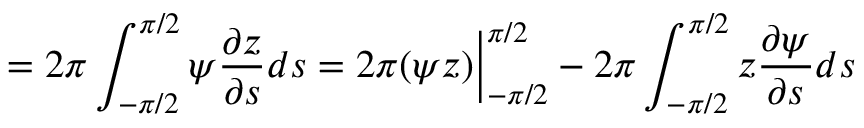<formula> <loc_0><loc_0><loc_500><loc_500>= 2 \pi \int _ { - \pi / 2 } ^ { \pi / 2 } \psi \frac { \partial z } { \partial s } d s = 2 \pi ( \psi z ) \Big | _ { - \pi / 2 } ^ { \pi / 2 } - 2 \pi \int _ { - \pi / 2 } ^ { \pi / 2 } z \frac { \partial \psi } { \partial s } d s</formula> 